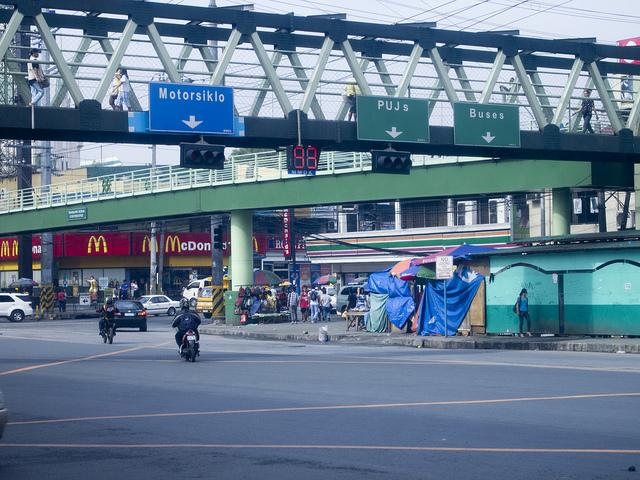What is the meaning of the arrows on the sign? lanes 